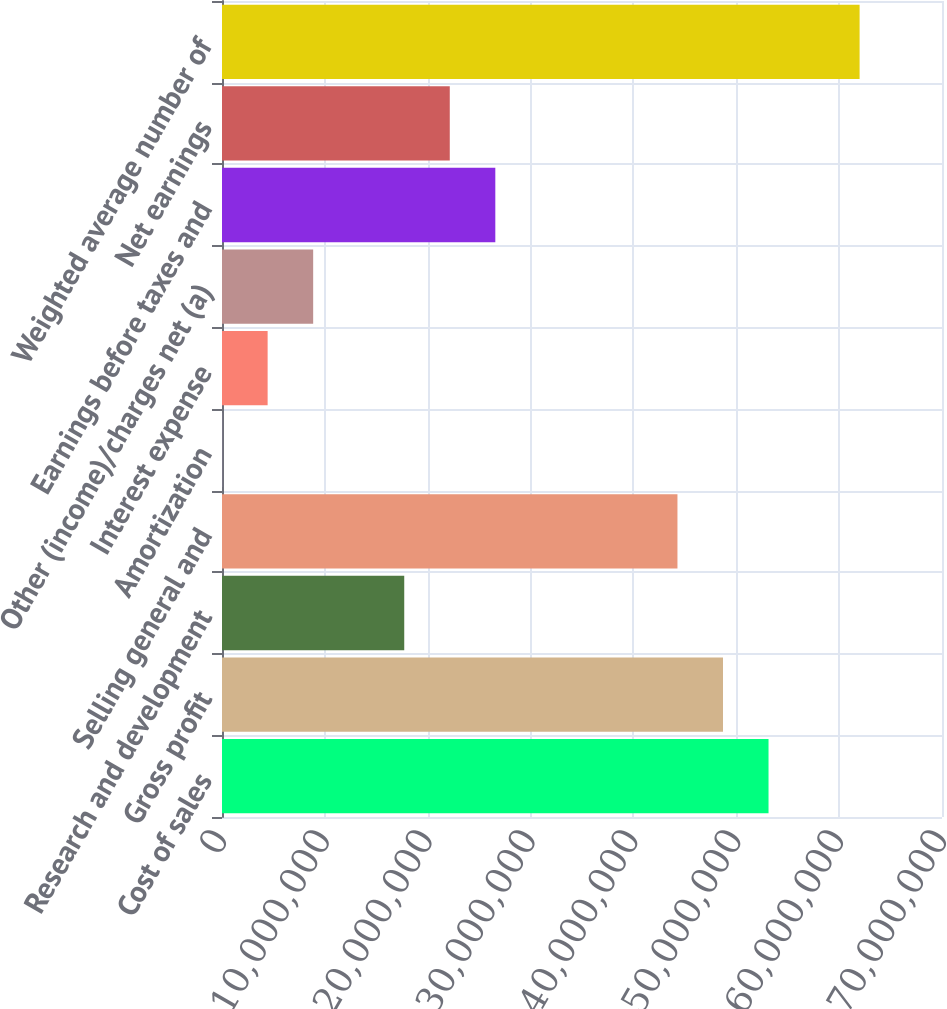Convert chart to OTSL. <chart><loc_0><loc_0><loc_500><loc_500><bar_chart><fcel>Cost of sales<fcel>Gross profit<fcel>Research and development<fcel>Selling general and<fcel>Amortization<fcel>Interest expense<fcel>Other (income)/charges net (a)<fcel>Earnings before taxes and<fcel>Net earnings<fcel>Weighted average number of<nl><fcel>5.31349e+07<fcel>4.87077e+07<fcel>1.77178e+07<fcel>4.42806e+07<fcel>9332<fcel>4.43646e+06<fcel>8.86359e+06<fcel>2.65721e+07<fcel>2.2145e+07<fcel>6.19891e+07<nl></chart> 